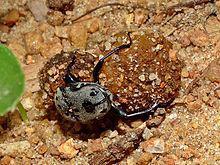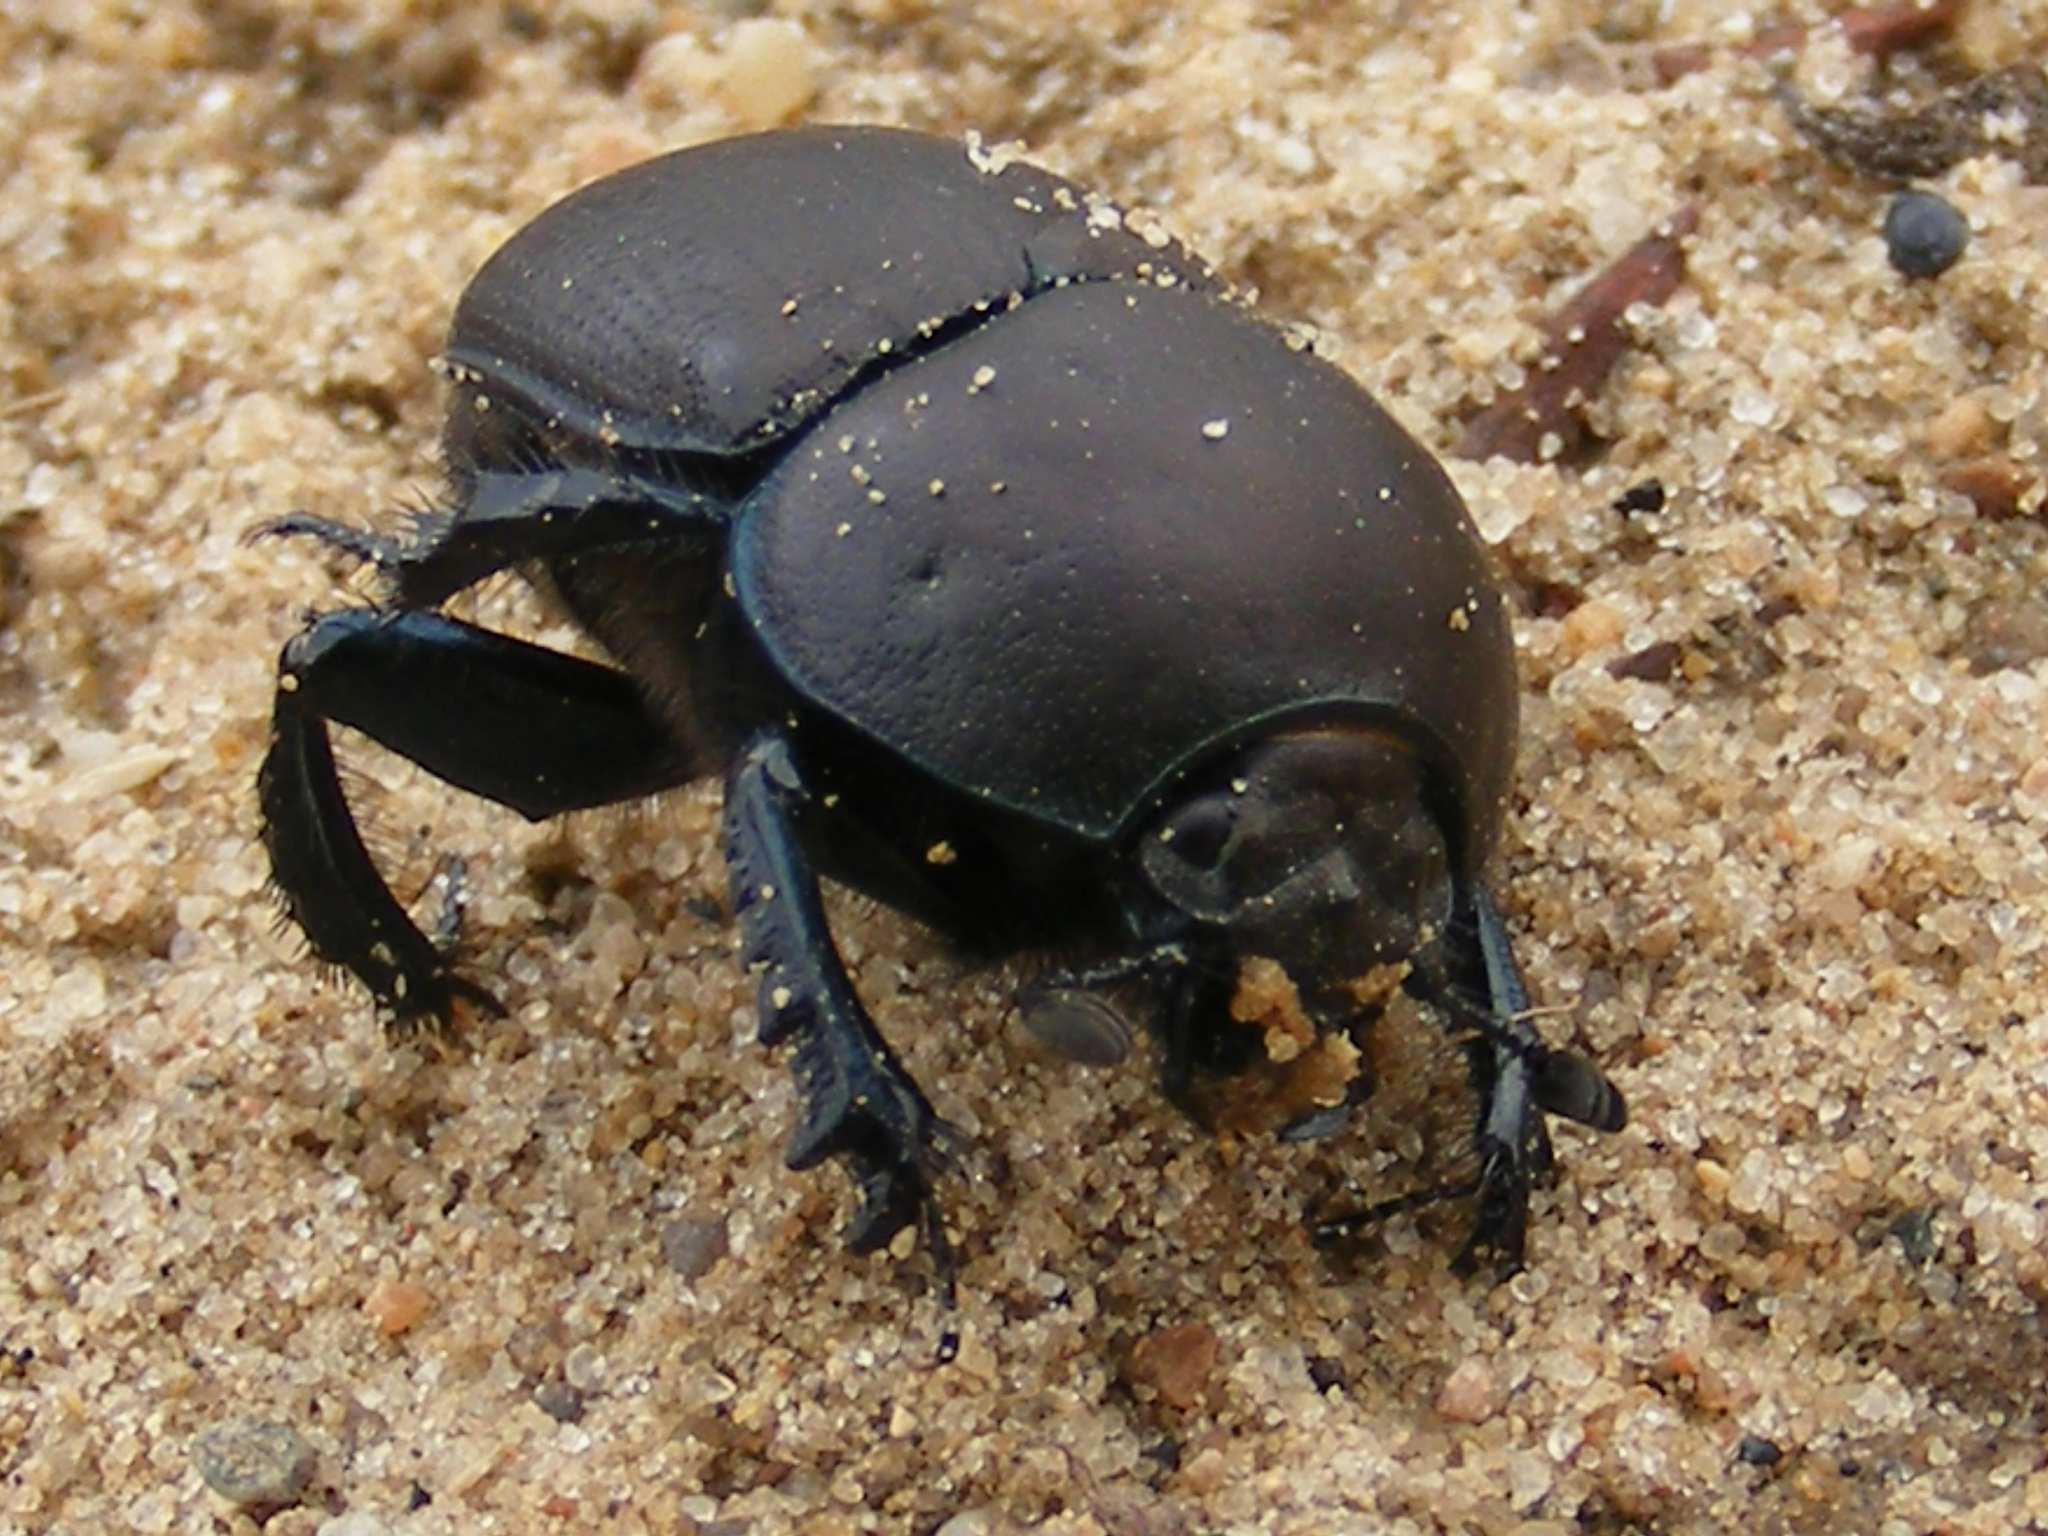The first image is the image on the left, the second image is the image on the right. Assess this claim about the two images: "An image shows a beetle without a dung ball.". Correct or not? Answer yes or no. Yes. 